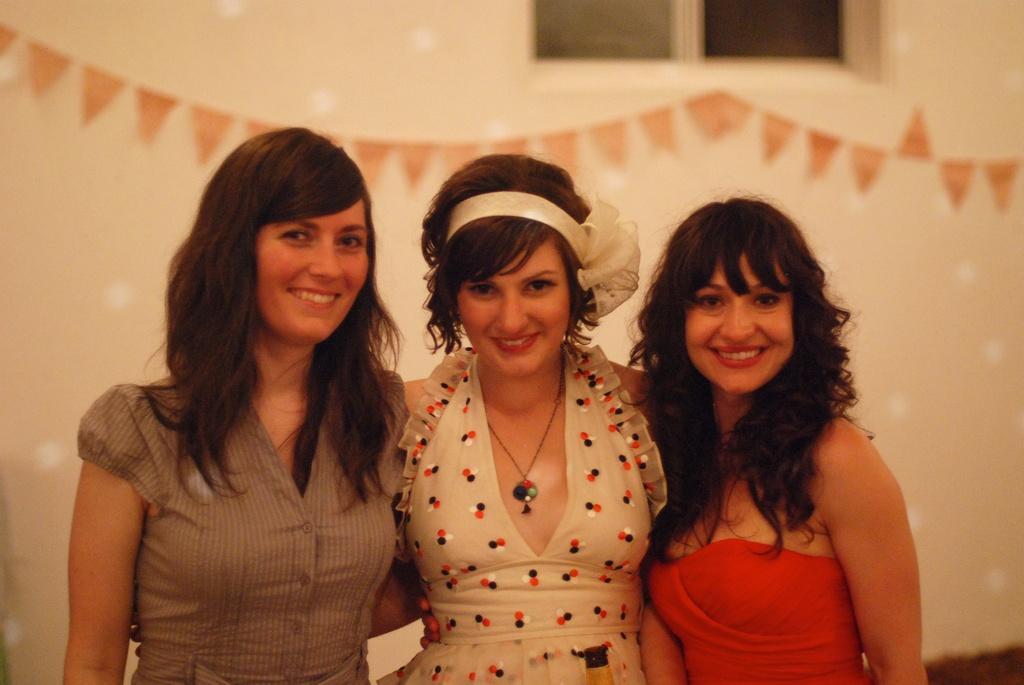Describe this image in one or two sentences. In this image we can see three women are standing and smiling. In the background there are decorative papers on the wall and window. 